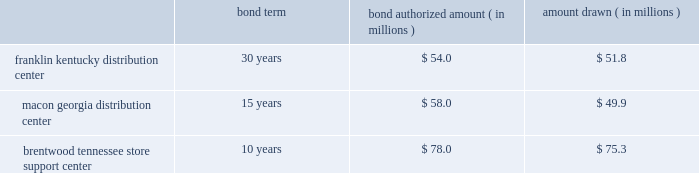The company entered into agreements with various governmental entities in the states of kentucky , georgia and tennessee to implement tax abatement plans related to its distribution center in franklin , kentucky ( simpson county ) , its distribution center in macon , georgia ( bibb county ) , and its store support center in brentwood , tennessee ( williamson county ) .
The tax abatement plans provide for reduction of real property taxes for specified time frames by legally transferring title to its real property in exchange for industrial revenue bonds .
This property was then leased back to the company .
No cash was exchanged .
The lease payments are equal to the amount of the payments on the bonds .
The tax abatement period extends through the term of the lease , which coincides with the maturity date of the bonds .
At any time , the company has the option to purchase the real property by paying off the bonds , plus $ 1 .
The terms and amounts authorized and drawn under each industrial revenue bond agreement are outlined as follows , as of december 30 , 2017 : bond term bond authorized amount ( in millions ) amount drawn ( in millions ) .
Due to the form of these transactions , the company has not recorded the bonds or the lease obligation associated with the sale lease-back transaction .
The original cost of the company 2019s property and equipment is recorded on the balance sheet and is being depreciated over its estimated useful life .
Capitalized software costs the company capitalizes certain costs related to the acquisition and development of software and amortizes these costs using the straight-line method over the estimated useful life of the software , which is three to five years .
Computer software consists of software developed for internal use and third-party software purchased for internal use .
A subsequent addition , modification or upgrade to internal-use software is capitalized to the extent that it enhances the software 2019s functionality or extends its useful life .
These costs are included in computer software and hardware in the accompanying consolidated balance sheets .
Certain software costs not meeting the criteria for capitalization are expensed as incurred .
Store closing costs the company regularly evaluates the performance of its stores and periodically closes those that are under-performing .
The company records a liability for costs associated with an exit or disposal activity when the liability is incurred , usually in the period the store closes .
Store closing costs were not significant to the results of operations for any of the fiscal years presented .
Leases assets under capital leases are amortized in accordance with the company 2019s normal depreciation policy for owned assets or over the lease term , if shorter , and the related charge to operations is included in depreciation expense in the consolidated statements of income .
Certain operating leases include rent increases during the lease term .
For these leases , the company recognizes the related rental expense on a straight-line basis over the term of the lease ( which includes the pre-opening period of construction , renovation , fixturing and merchandise placement ) and records the difference between the expense charged to operations and amounts paid as a deferred rent liability .
The company occasionally receives reimbursements from landlords to be used towards improving the related store to be leased .
Leasehold improvements are recorded at their gross costs , including items reimbursed by landlords .
Related reimbursements are deferred and amortized on a straight-line basis as a reduction of rent expense over the applicable lease term .
Note 2 - share-based compensation : share-based compensation includes stock option and restricted stock unit awards and certain transactions under the company 2019s espp .
Share-based compensation expense is recognized based on the grant date fair value of all stock option and restricted stock unit awards plus a discount on shares purchased by employees as a part of the espp .
The discount under the espp represents the difference between the purchase date market value and the employee 2019s purchase price. .
What was the total amount lost from the bond authorization to the withdrawn? 
Rationale: to find out the amount of money lost we must compare the authorization to the withdraw of all 3 bonds . then once you find the difference of these bonds you will add together the differences to get $ 13 million
Computations: ((54.0 - 51.8) + ((78.0 - 75.3) + (58.0 - 49.9)))
Answer: 13.0. 